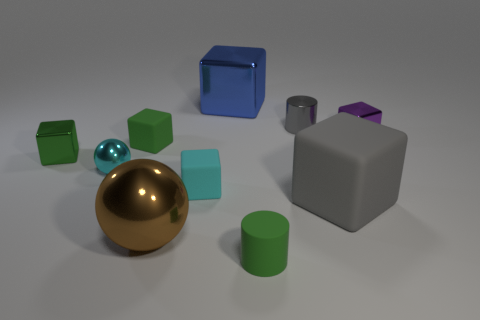What number of gray matte cubes are to the left of the green rubber object that is behind the tiny green rubber cylinder?
Give a very brief answer. 0. Do the tiny matte cylinder and the small cylinder that is behind the small green matte cylinder have the same color?
Ensure brevity in your answer.  No. There is a rubber thing that is the same size as the blue shiny thing; what color is it?
Your answer should be very brief. Gray. Is there a big blue metal object of the same shape as the green shiny object?
Provide a succinct answer. Yes. Is the number of gray cylinders less than the number of big green cylinders?
Your answer should be compact. No. What color is the thing in front of the large brown metal thing?
Your answer should be very brief. Green. There is a small green matte object behind the small green matte thing in front of the large rubber thing; what is its shape?
Ensure brevity in your answer.  Cube. Is the gray block made of the same material as the large cube that is behind the small gray metal object?
Your answer should be compact. No. The tiny matte object that is the same color as the small rubber cylinder is what shape?
Give a very brief answer. Cube. How many brown metal balls are the same size as the purple cube?
Your response must be concise. 0. 